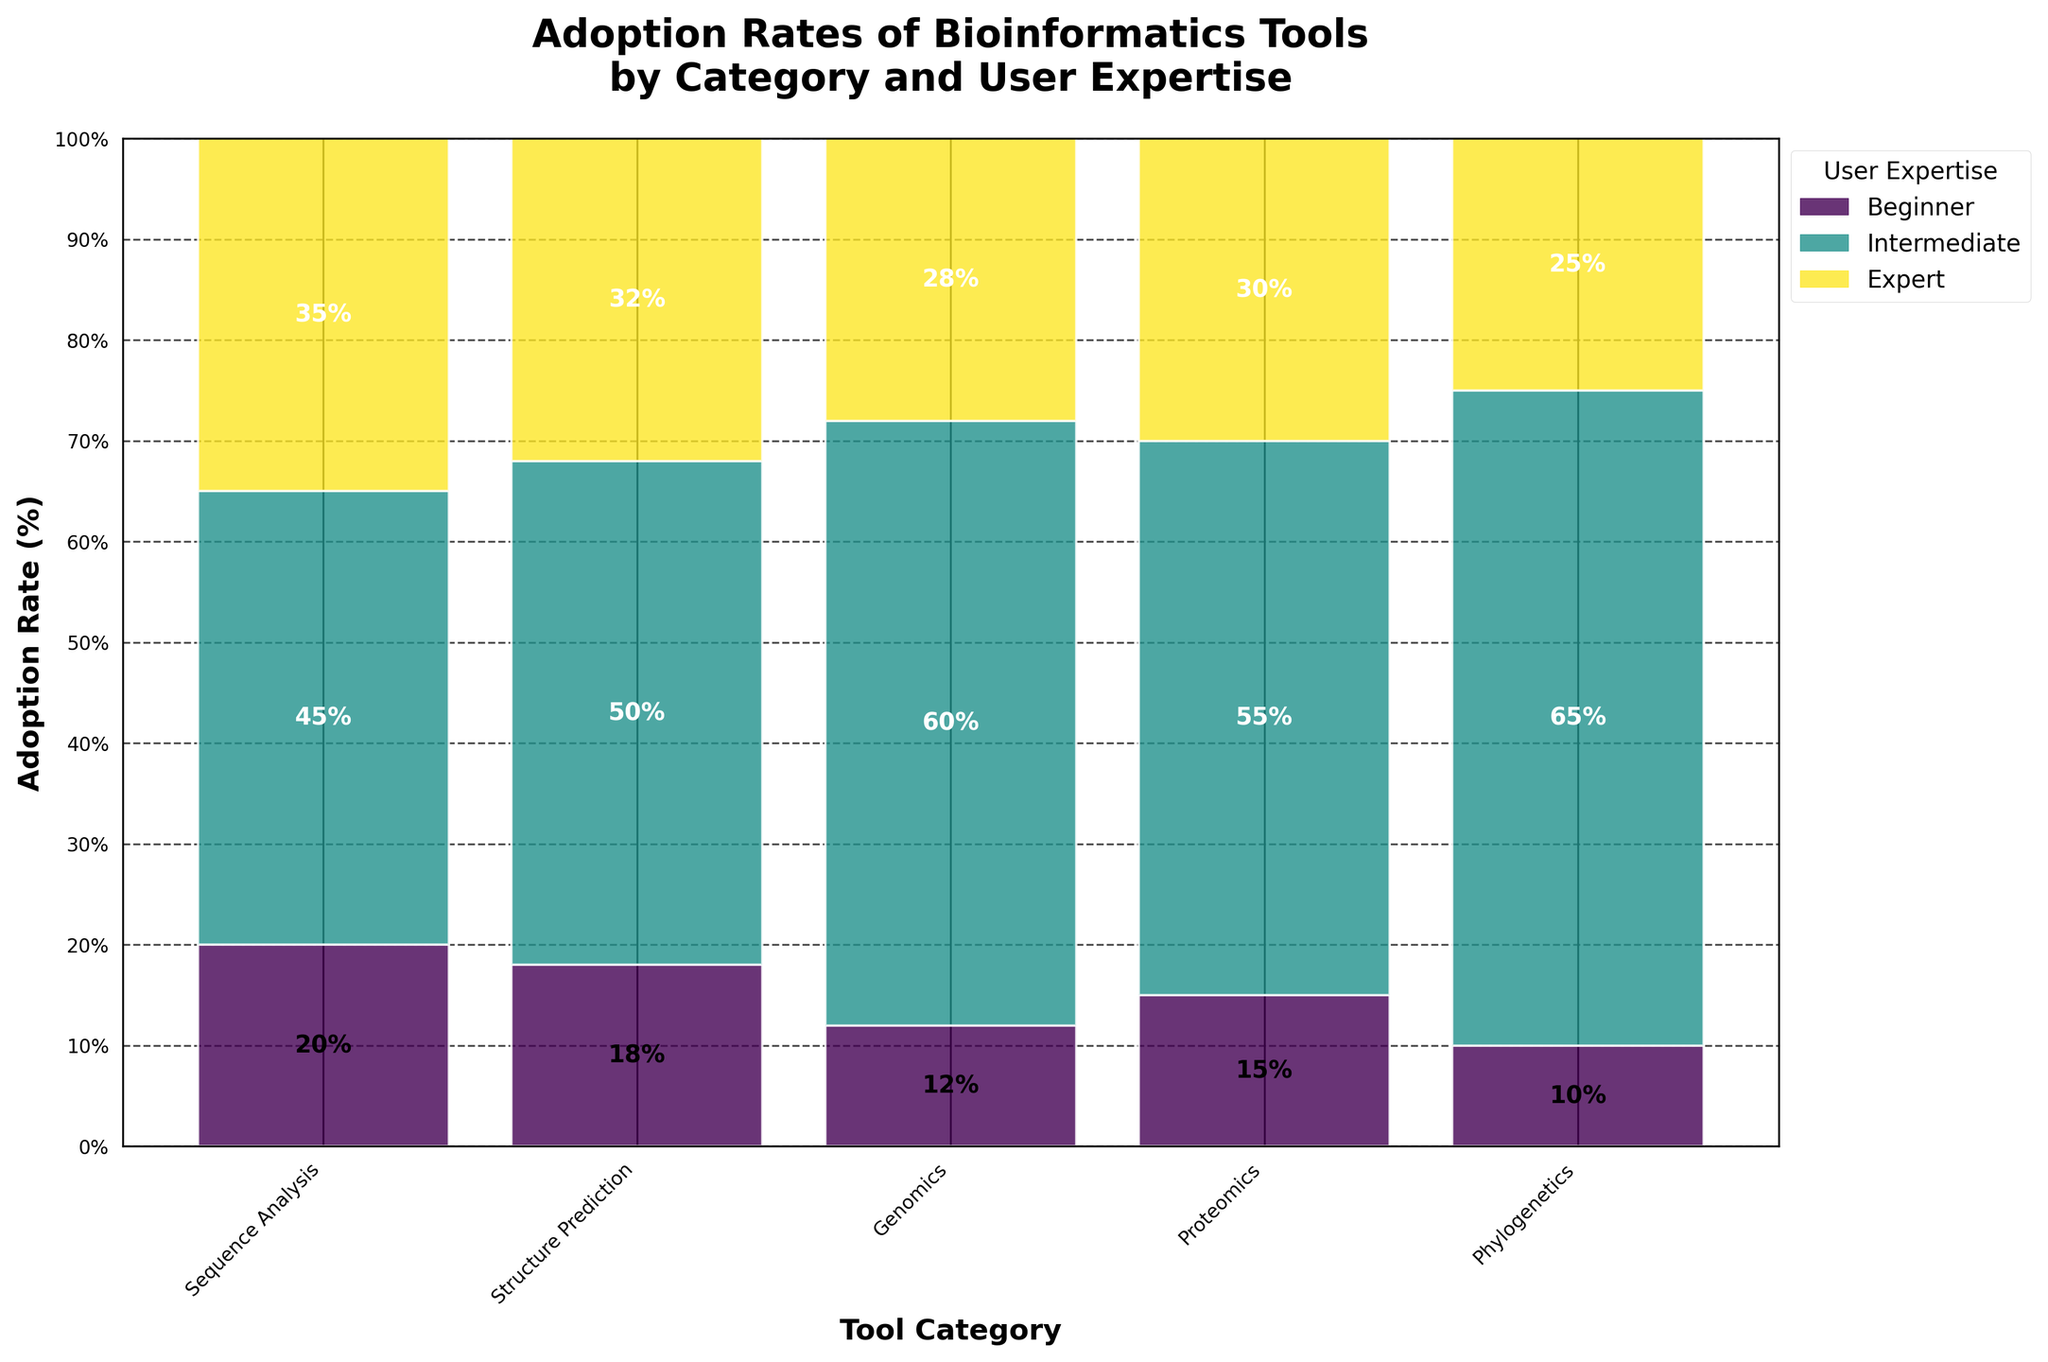Which bioinformatics tool category has the highest adoption rate among experts? Look at the segment in the plot that represents experts for each tool category. The tallest segment among these is for Structure Prediction.
Answer: Structure Prediction What is the total adoption rate for Sequence Analysis? Sum the adoption rates of Sequence Analysis across all user expertise levels (15 for Beginners, 30 for Intermediates, and 55 for Experts). 15 + 30 + 55 = 100.
Answer: 100% How does the adoption rate for Proteomics among Beginners compare to that among Experts? Compare the height of the patches representing Beginners and Experts for Proteomics. The adoption rate for Beginners is 12%, while for Experts, it is 60%.
Answer: Experts have a higher rate Which user expertise level shows the highest adoption rate for Genomics? Identify the tallest segment within the Genomics category. The tallest segment corresponds to Intermediates, with a rate of 35%.
Answer: Intermediate What percentage of the total adoption rate does Structure Prediction contribute for Intermediate users? To find the percentage, divide the adoption rate of Intermediate users for Structure Prediction (25%) by the total adoption rate of Structure Prediction (10% for Beginners + 25% for Intermediate + 65% for Experts = 100%), then multiply by 100. (25/100) x 100 = 25%.
Answer: 25% What is the main color associated with Sequence Analysis users who are beginners? Identify the color of the segment representing beginners in the Sequence Analysis category. The plot uses a color gradient, often with the first color corresponding to beginners. The color is consistent with the first segment in the color legend.
Answer: Light color from the gradient What is the adoption rate difference between Experts using Phylogenetics and Experts using Genomics? Subtract the adoption rate of Experts in Genomics (45%) from the adoption rate of Experts in Phylogenetics (50%). 50% - 45% = 5%.
Answer: 5% What is the average adoption rate for all user expertise levels across all categories? Sum all the adoption rates and divide by the number of data points. The total adoption rate is 480% (sum of all provided rates). There are 15 data points (5 categories each with 3 levels), so the average is 480/15.
Answer: 32% Which tool category shows the smallest difference in adoption rates between Beginners and Intermediates? For each category, compute the difference between the Beginner and Intermediate adoption rates. The smallest difference is for Proteomics (28% - 12% = 16%).
Answer: Proteomics How does the adoption rate for Sequence Analysis among Intermediate users compare to that of Genomics among Beginners? Compare the adoption rates directly from the plot. Sequence Analysis among Intermediate users is 30%, while Genomics among Beginners is 20%.
Answer: Higher 